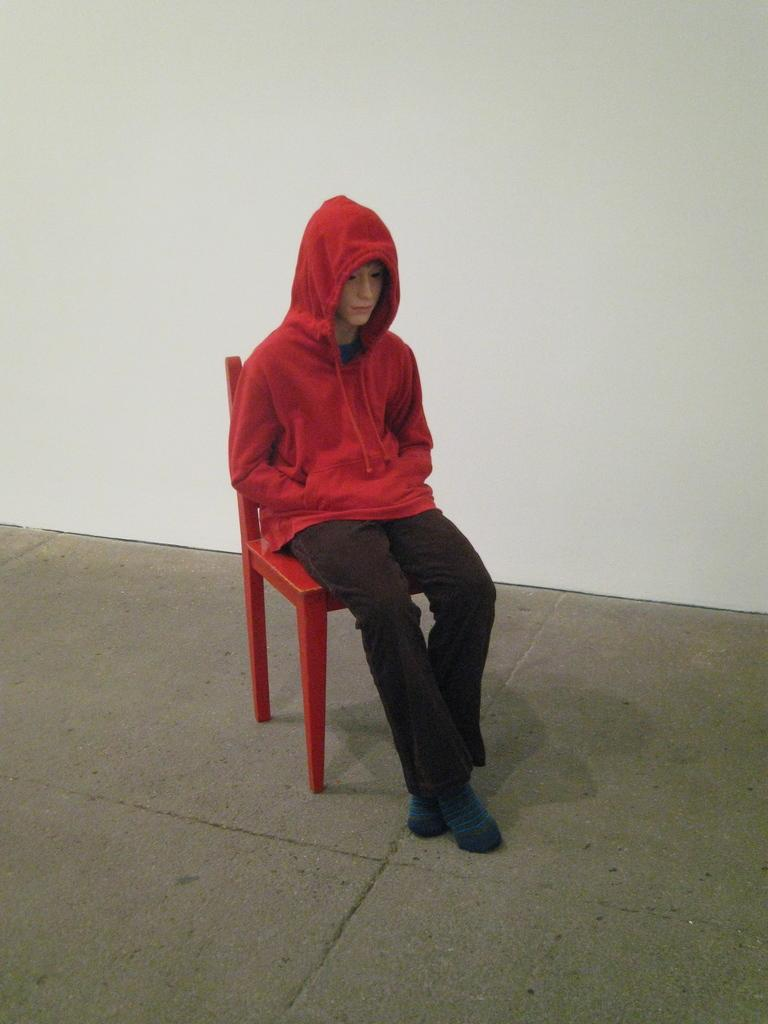What is the person in the image doing? The person is sitting on a chair in the image. What is the person wearing while sitting on the chair? The person is wearing clothes and socks. What can be seen beneath the person's feet in the image? There is a floor visible in the image. What is visible behind the person in the image? There is a wall visible in the image. How does the person in the image answer the surprise question about transportation? There is no surprise question about transportation in the image, as the focus is on the person sitting on a chair and their clothing. 